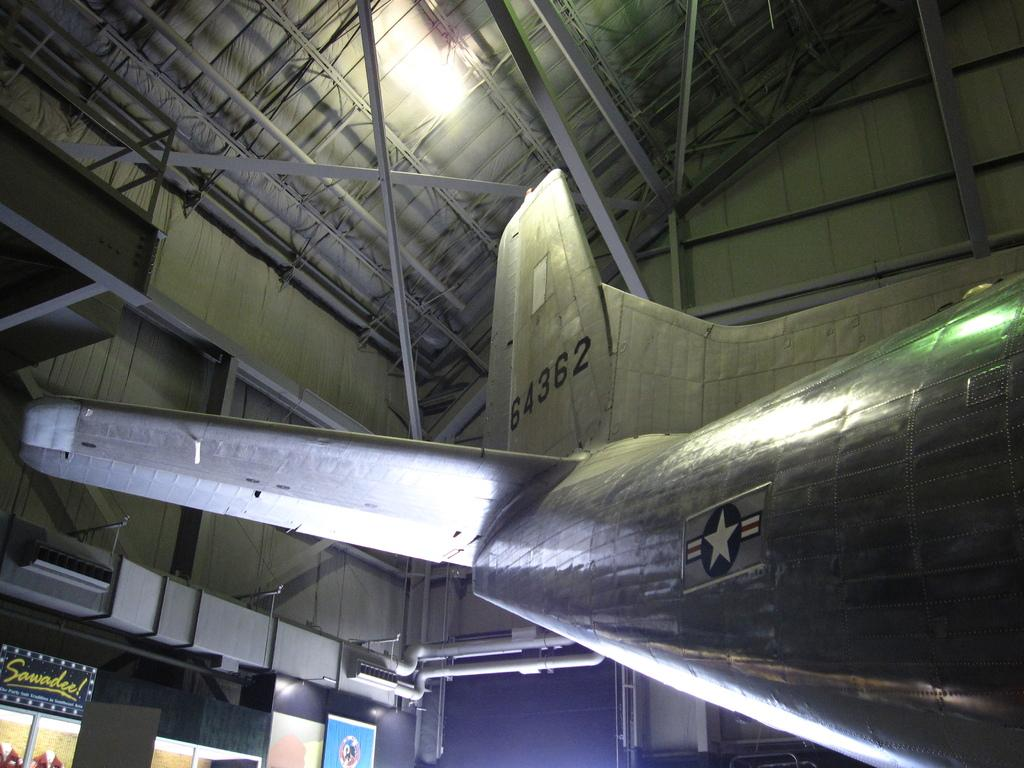What is the main subject of the picture? The main subject of the picture is an aircraft. What can be seen on the left side of the picture? There are posters on the left side of the picture. What type of structures are visible in the picture? Pipes and iron frames are visible in the picture. What is the source of light in the picture? The light of the ceiling is visible in the picture. What reason: What is the reason behind the movement of the trains in the picture? There are no trains present in the picture, so there is no reason to discuss their movement. 